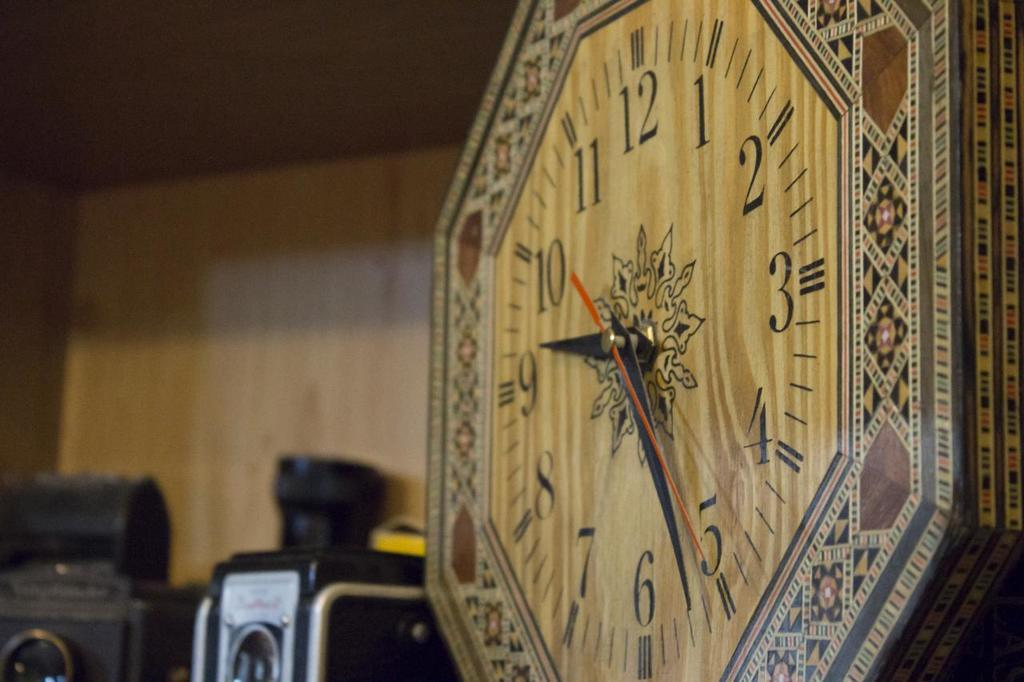Provide a one-sentence caption for the provided image. A wooden clock face shows the time at 9:26. 